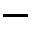<formula> <loc_0><loc_0><loc_500><loc_500>-</formula> 